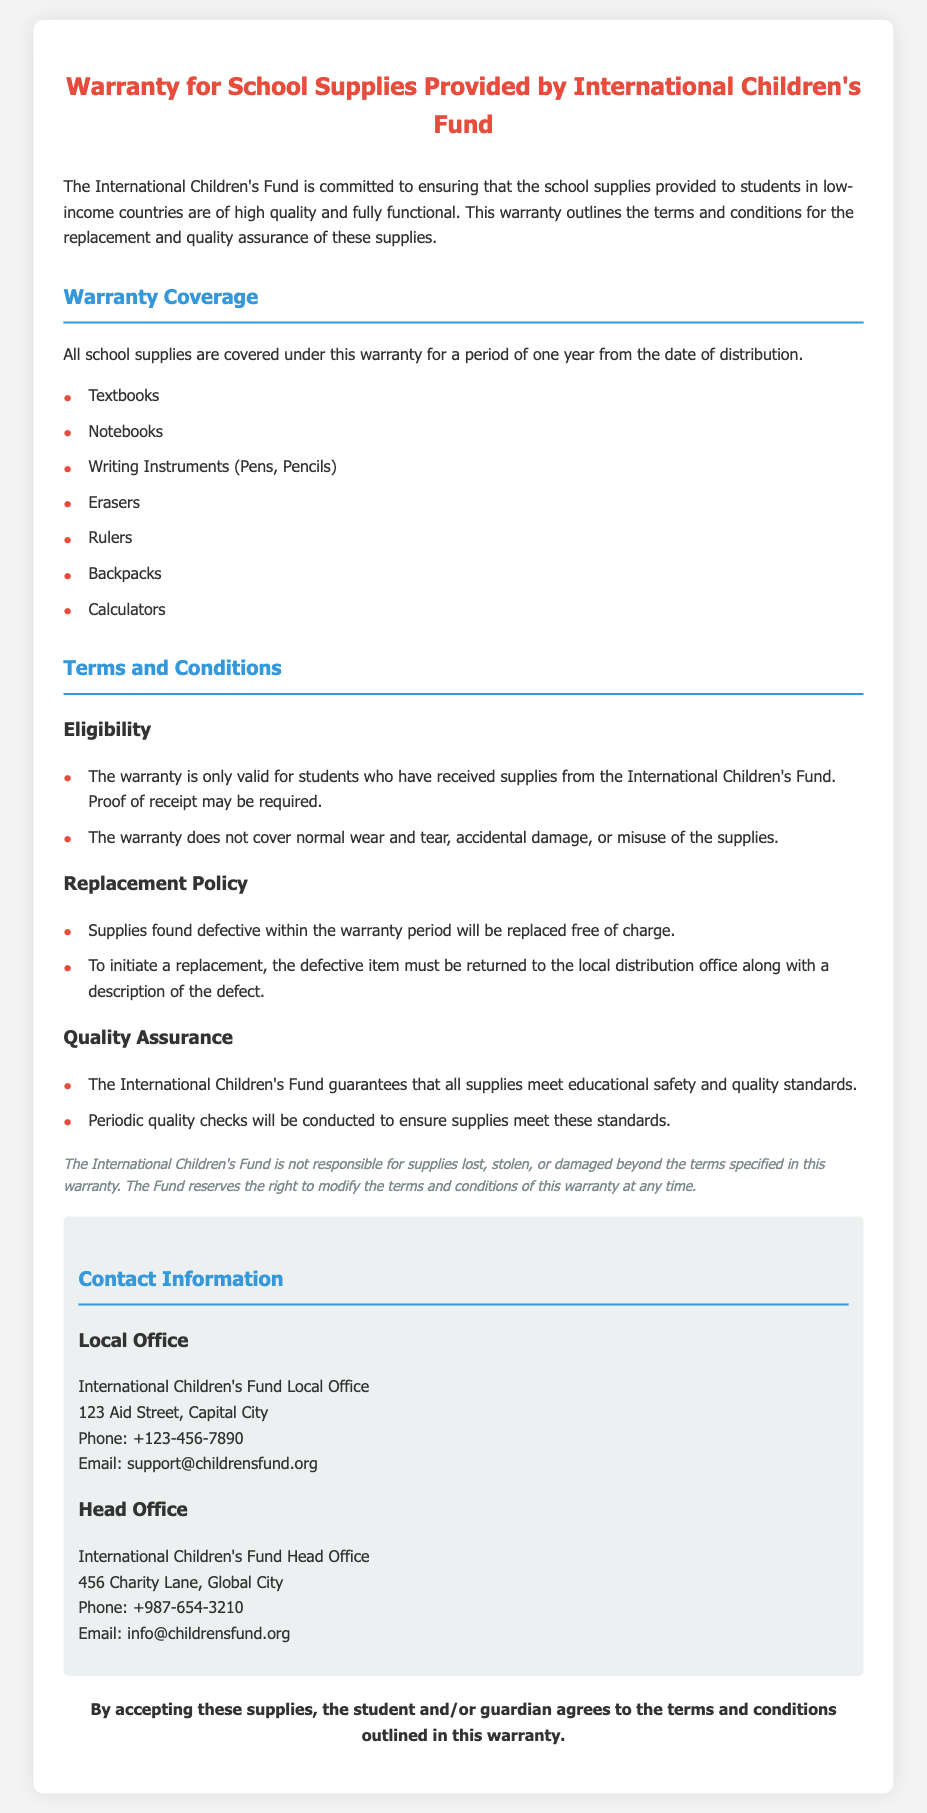What is the warranty period for school supplies? The document states that all school supplies are covered under this warranty for a period of one year from the date of distribution.
Answer: One year Who provides the school supplies? The document identifies the International Children's Fund as the organization that provides the school supplies.
Answer: International Children's Fund Which items are included in the warranty coverage? The document lists textbooks, notebooks, writing instruments, erasers, rulers, backpacks, and calculators as covered items.
Answer: Textbooks, notebooks, writing instruments, erasers, rulers, backpacks, calculators What must be returned to initiate a replacement? The document specifies that the defective item must be returned to the local distribution office along with a description of the defect to initiate a replacement.
Answer: Defective item What type of damage is not covered by the warranty? The warranty does not cover normal wear and tear, accidental damage, or misuse of the supplies according to the document.
Answer: Normal wear and tear Is there an eligibility requirement mentioned for the warranty? The document states that the warranty is only valid for students who have received supplies from the International Children's Fund.
Answer: Yes How often will quality checks be conducted? The document does not specify a frequency but states that periodic quality checks will be conducted to ensure supplies meet standards.
Answer: Periodic What is the contact number for the local office? The contact number for the local office is provided in the document as +123-456-7890.
Answer: +123-456-7890 Who should be contacted for issues related to the warranty? The document lists the International Children's Fund local and head offices' contact information for any issues.
Answer: International Children's Fund 